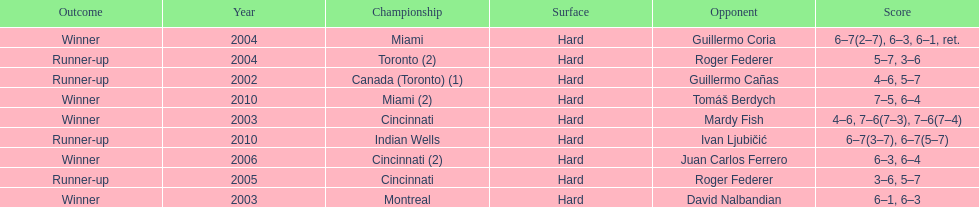How many times was the championship in miami? 2. 